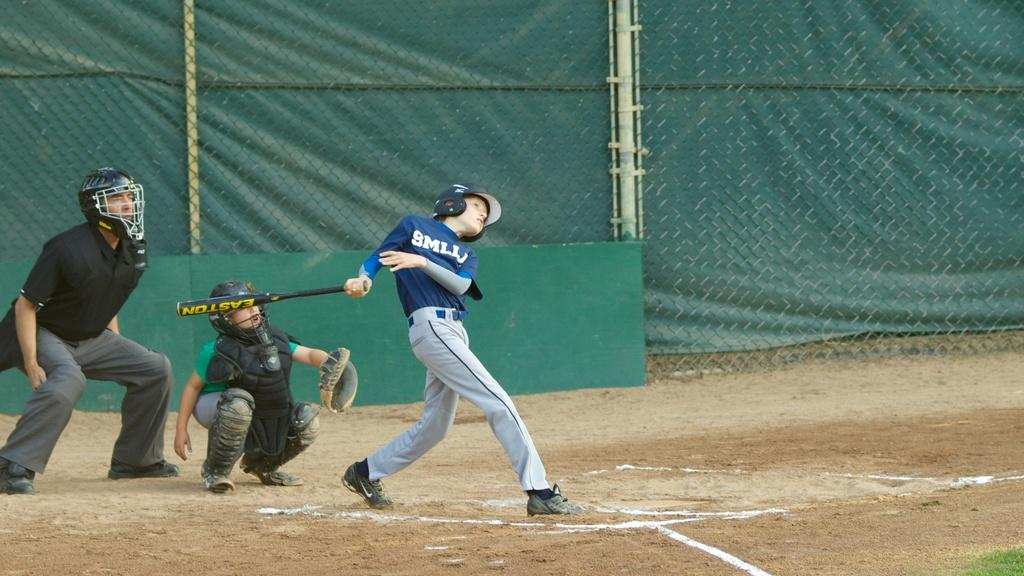<image>
Offer a succinct explanation of the picture presented. A young baseball player has just swung an Easton bat on a field. 